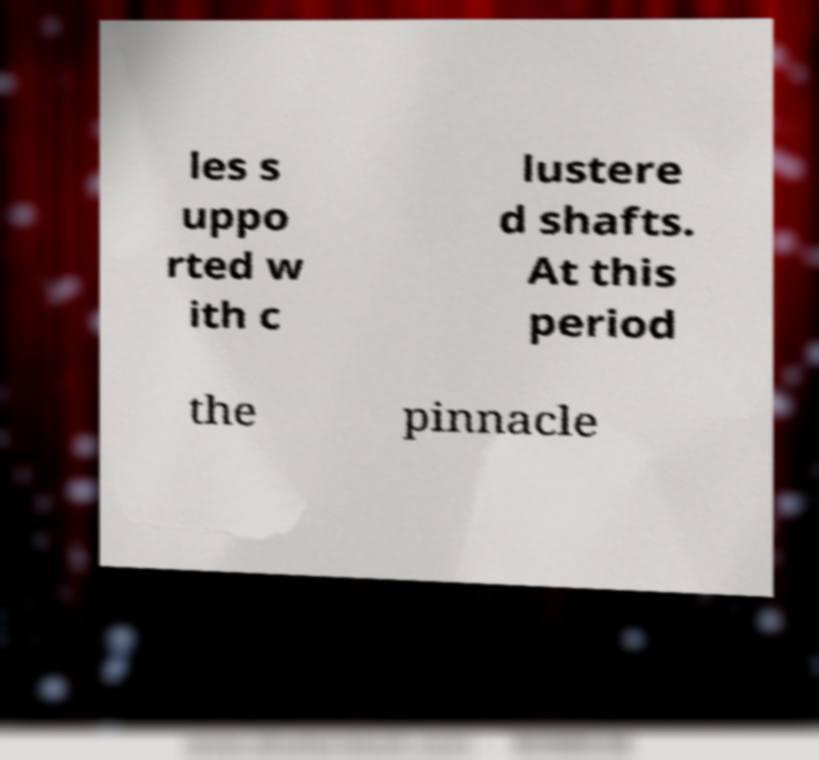Could you extract and type out the text from this image? les s uppo rted w ith c lustere d shafts. At this period the pinnacle 